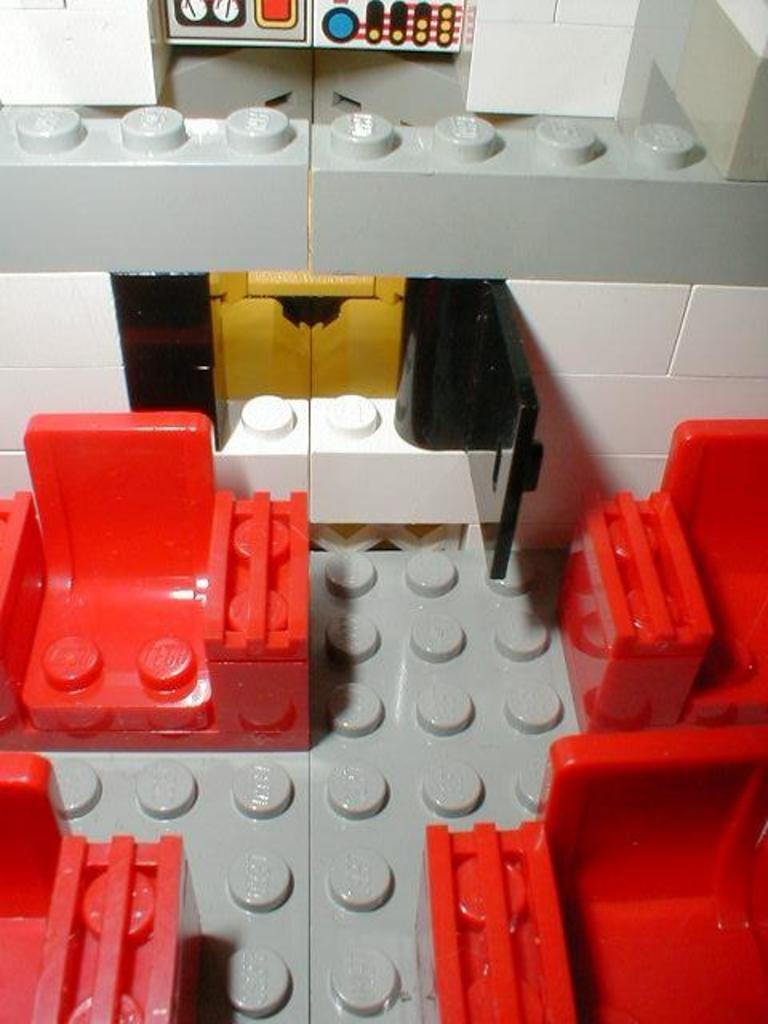What type of toy is present in the image? There are lego bricks in the image. What colors can be seen among the lego bricks? The lego bricks are red, grey, and white in color. Can you describe the painting of a cow in the image? There is no painting or cow present in the image; it features lego bricks in red, grey, and white colors. 